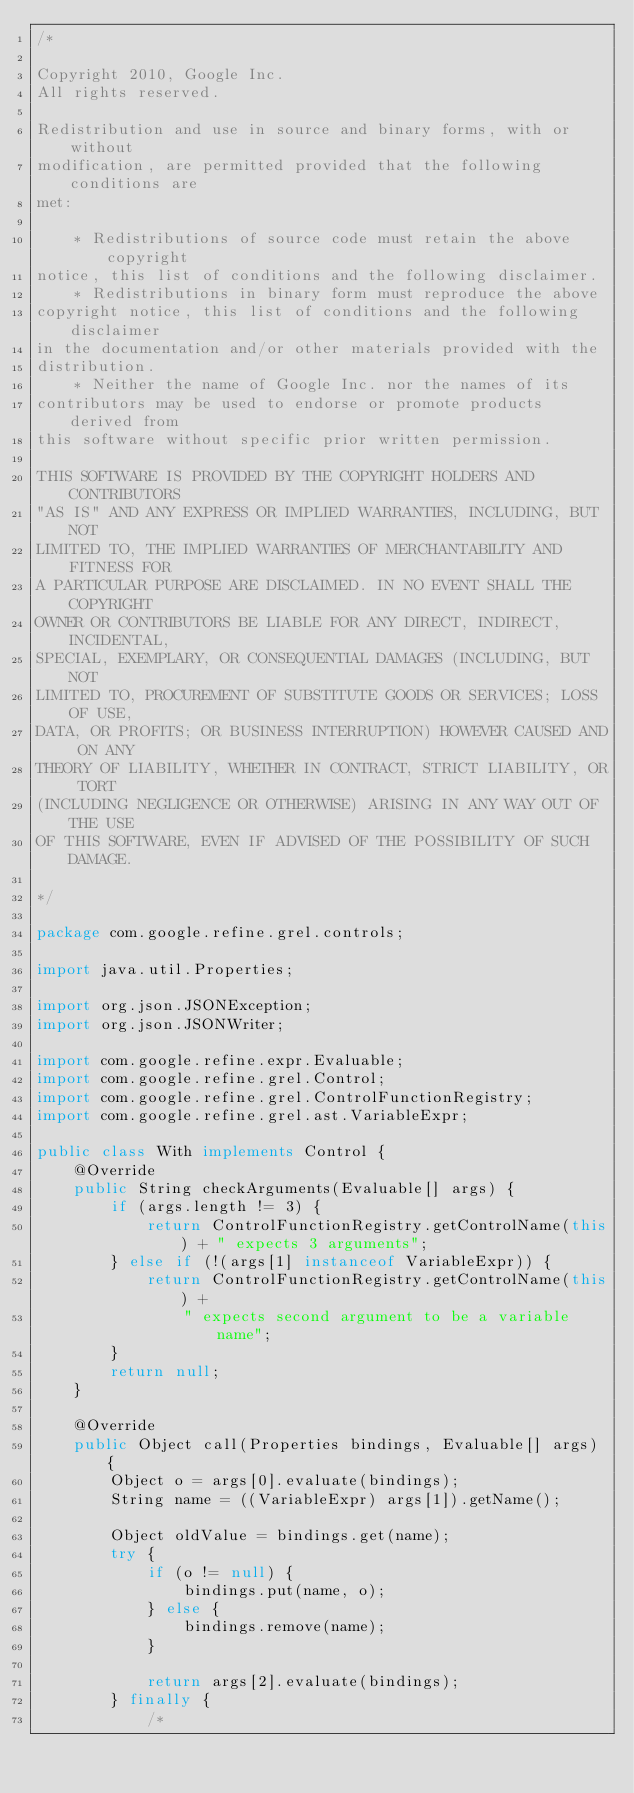<code> <loc_0><loc_0><loc_500><loc_500><_Java_>/*

Copyright 2010, Google Inc.
All rights reserved.

Redistribution and use in source and binary forms, with or without
modification, are permitted provided that the following conditions are
met:

    * Redistributions of source code must retain the above copyright
notice, this list of conditions and the following disclaimer.
    * Redistributions in binary form must reproduce the above
copyright notice, this list of conditions and the following disclaimer
in the documentation and/or other materials provided with the
distribution.
    * Neither the name of Google Inc. nor the names of its
contributors may be used to endorse or promote products derived from
this software without specific prior written permission.

THIS SOFTWARE IS PROVIDED BY THE COPYRIGHT HOLDERS AND CONTRIBUTORS
"AS IS" AND ANY EXPRESS OR IMPLIED WARRANTIES, INCLUDING, BUT NOT
LIMITED TO, THE IMPLIED WARRANTIES OF MERCHANTABILITY AND FITNESS FOR
A PARTICULAR PURPOSE ARE DISCLAIMED. IN NO EVENT SHALL THE COPYRIGHT
OWNER OR CONTRIBUTORS BE LIABLE FOR ANY DIRECT, INDIRECT, INCIDENTAL,
SPECIAL, EXEMPLARY, OR CONSEQUENTIAL DAMAGES (INCLUDING, BUT NOT
LIMITED TO, PROCUREMENT OF SUBSTITUTE GOODS OR SERVICES; LOSS OF USE,           
DATA, OR PROFITS; OR BUSINESS INTERRUPTION) HOWEVER CAUSED AND ON ANY           
THEORY OF LIABILITY, WHETHER IN CONTRACT, STRICT LIABILITY, OR TORT
(INCLUDING NEGLIGENCE OR OTHERWISE) ARISING IN ANY WAY OUT OF THE USE
OF THIS SOFTWARE, EVEN IF ADVISED OF THE POSSIBILITY OF SUCH DAMAGE.

*/

package com.google.refine.grel.controls;

import java.util.Properties;

import org.json.JSONException;
import org.json.JSONWriter;

import com.google.refine.expr.Evaluable;
import com.google.refine.grel.Control;
import com.google.refine.grel.ControlFunctionRegistry;
import com.google.refine.grel.ast.VariableExpr;

public class With implements Control {
    @Override
    public String checkArguments(Evaluable[] args) {
        if (args.length != 3) {
            return ControlFunctionRegistry.getControlName(this) + " expects 3 arguments";
        } else if (!(args[1] instanceof VariableExpr)) {
            return ControlFunctionRegistry.getControlName(this) + 
                " expects second argument to be a variable name";
        }
        return null;
    }

    @Override
    public Object call(Properties bindings, Evaluable[] args) {
        Object o = args[0].evaluate(bindings);
        String name = ((VariableExpr) args[1]).getName();
        
        Object oldValue = bindings.get(name);
        try {
            if (o != null) {
                bindings.put(name, o);
            } else {
                bindings.remove(name);
            }
            
            return args[2].evaluate(bindings);
        } finally {
            /*</code> 